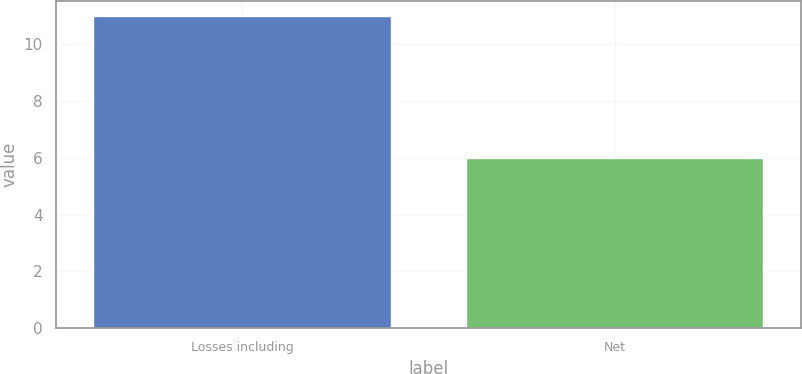Convert chart. <chart><loc_0><loc_0><loc_500><loc_500><bar_chart><fcel>Losses including<fcel>Net<nl><fcel>11<fcel>6<nl></chart> 